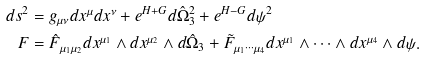Convert formula to latex. <formula><loc_0><loc_0><loc_500><loc_500>d s ^ { 2 } & = g _ { \mu \nu } d x ^ { \mu } d x ^ { \nu } + e ^ { H + G } d \hat { \Omega } _ { 3 } ^ { 2 } + e ^ { H - G } d \psi ^ { 2 } \\ F & = \hat { F } _ { \mu _ { 1 } \mu _ { 2 } } d x ^ { \mu _ { 1 } } \wedge d x ^ { \mu _ { 2 } } \wedge d \hat { \Omega } _ { 3 } + \tilde { F } _ { \mu _ { 1 } \cdots \mu _ { 4 } } d x ^ { \mu _ { 1 } } \wedge \cdots \wedge d x ^ { \mu _ { 4 } } \wedge d \psi .</formula> 